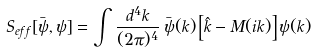Convert formula to latex. <formula><loc_0><loc_0><loc_500><loc_500>S _ { e f f } [ \bar { \psi } , \psi ] = \int \frac { d ^ { 4 } k } { ( 2 \pi ) ^ { 4 } } \, \bar { \psi } ( k ) \left [ \hat { k } - M ( i k ) \right ] \psi ( k )</formula> 